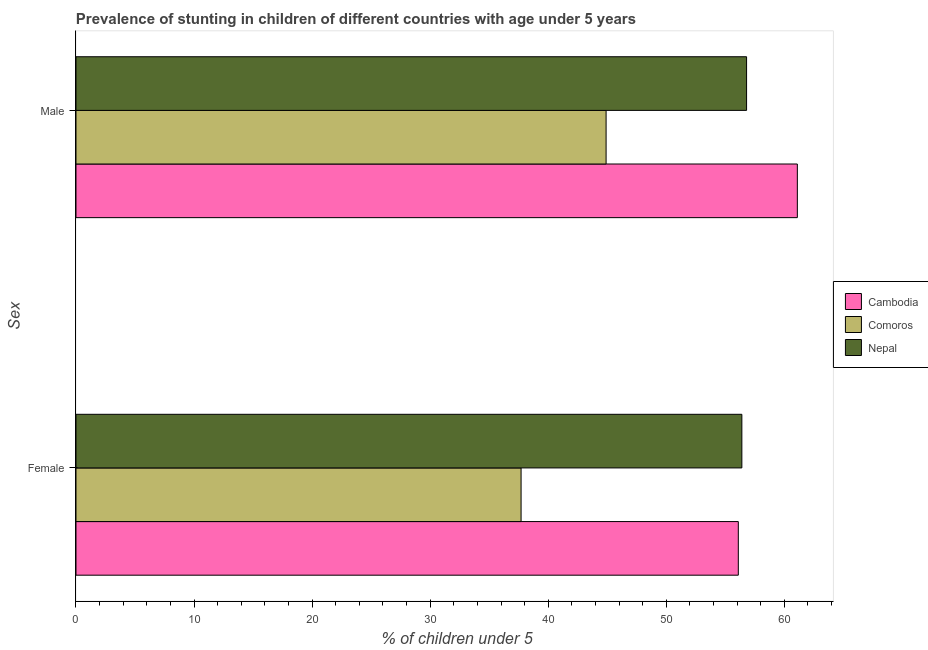How many groups of bars are there?
Offer a terse response. 2. How many bars are there on the 2nd tick from the top?
Ensure brevity in your answer.  3. What is the percentage of stunted male children in Nepal?
Ensure brevity in your answer.  56.8. Across all countries, what is the maximum percentage of stunted male children?
Give a very brief answer. 61.1. Across all countries, what is the minimum percentage of stunted male children?
Make the answer very short. 44.9. In which country was the percentage of stunted female children maximum?
Offer a terse response. Nepal. In which country was the percentage of stunted female children minimum?
Make the answer very short. Comoros. What is the total percentage of stunted male children in the graph?
Ensure brevity in your answer.  162.8. What is the difference between the percentage of stunted female children in Cambodia and that in Comoros?
Your answer should be very brief. 18.4. What is the difference between the percentage of stunted female children in Nepal and the percentage of stunted male children in Comoros?
Your answer should be compact. 11.5. What is the average percentage of stunted female children per country?
Your answer should be compact. 50.07. What is the difference between the percentage of stunted female children and percentage of stunted male children in Comoros?
Provide a succinct answer. -7.2. What is the ratio of the percentage of stunted male children in Comoros to that in Cambodia?
Ensure brevity in your answer.  0.73. In how many countries, is the percentage of stunted male children greater than the average percentage of stunted male children taken over all countries?
Keep it short and to the point. 2. What does the 3rd bar from the top in Female represents?
Provide a short and direct response. Cambodia. What does the 3rd bar from the bottom in Female represents?
Your answer should be compact. Nepal. Does the graph contain any zero values?
Your response must be concise. No. Where does the legend appear in the graph?
Ensure brevity in your answer.  Center right. How are the legend labels stacked?
Your answer should be very brief. Vertical. What is the title of the graph?
Keep it short and to the point. Prevalence of stunting in children of different countries with age under 5 years. What is the label or title of the X-axis?
Offer a very short reply.  % of children under 5. What is the label or title of the Y-axis?
Make the answer very short. Sex. What is the  % of children under 5 in Cambodia in Female?
Your answer should be compact. 56.1. What is the  % of children under 5 in Comoros in Female?
Your answer should be very brief. 37.7. What is the  % of children under 5 of Nepal in Female?
Make the answer very short. 56.4. What is the  % of children under 5 in Cambodia in Male?
Ensure brevity in your answer.  61.1. What is the  % of children under 5 in Comoros in Male?
Offer a very short reply. 44.9. What is the  % of children under 5 of Nepal in Male?
Offer a terse response. 56.8. Across all Sex, what is the maximum  % of children under 5 of Cambodia?
Ensure brevity in your answer.  61.1. Across all Sex, what is the maximum  % of children under 5 of Comoros?
Keep it short and to the point. 44.9. Across all Sex, what is the maximum  % of children under 5 in Nepal?
Your answer should be very brief. 56.8. Across all Sex, what is the minimum  % of children under 5 in Cambodia?
Ensure brevity in your answer.  56.1. Across all Sex, what is the minimum  % of children under 5 of Comoros?
Ensure brevity in your answer.  37.7. Across all Sex, what is the minimum  % of children under 5 of Nepal?
Provide a short and direct response. 56.4. What is the total  % of children under 5 in Cambodia in the graph?
Your answer should be compact. 117.2. What is the total  % of children under 5 of Comoros in the graph?
Offer a terse response. 82.6. What is the total  % of children under 5 of Nepal in the graph?
Offer a terse response. 113.2. What is the difference between the  % of children under 5 of Cambodia in Female and that in Male?
Give a very brief answer. -5. What is the difference between the  % of children under 5 in Nepal in Female and that in Male?
Give a very brief answer. -0.4. What is the difference between the  % of children under 5 in Cambodia in Female and the  % of children under 5 in Comoros in Male?
Offer a very short reply. 11.2. What is the difference between the  % of children under 5 in Comoros in Female and the  % of children under 5 in Nepal in Male?
Offer a very short reply. -19.1. What is the average  % of children under 5 in Cambodia per Sex?
Offer a terse response. 58.6. What is the average  % of children under 5 of Comoros per Sex?
Provide a short and direct response. 41.3. What is the average  % of children under 5 in Nepal per Sex?
Provide a short and direct response. 56.6. What is the difference between the  % of children under 5 in Cambodia and  % of children under 5 in Comoros in Female?
Your answer should be very brief. 18.4. What is the difference between the  % of children under 5 of Comoros and  % of children under 5 of Nepal in Female?
Give a very brief answer. -18.7. What is the ratio of the  % of children under 5 in Cambodia in Female to that in Male?
Offer a very short reply. 0.92. What is the ratio of the  % of children under 5 of Comoros in Female to that in Male?
Ensure brevity in your answer.  0.84. What is the difference between the highest and the second highest  % of children under 5 in Cambodia?
Give a very brief answer. 5. What is the difference between the highest and the lowest  % of children under 5 in Cambodia?
Offer a terse response. 5. 